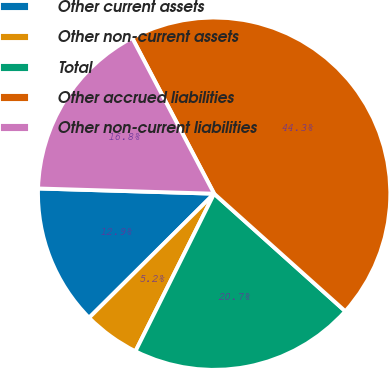Convert chart to OTSL. <chart><loc_0><loc_0><loc_500><loc_500><pie_chart><fcel>Other current assets<fcel>Other non-current assets<fcel>Total<fcel>Other accrued liabilities<fcel>Other non-current liabilities<nl><fcel>12.91%<fcel>5.19%<fcel>20.74%<fcel>44.34%<fcel>16.82%<nl></chart> 